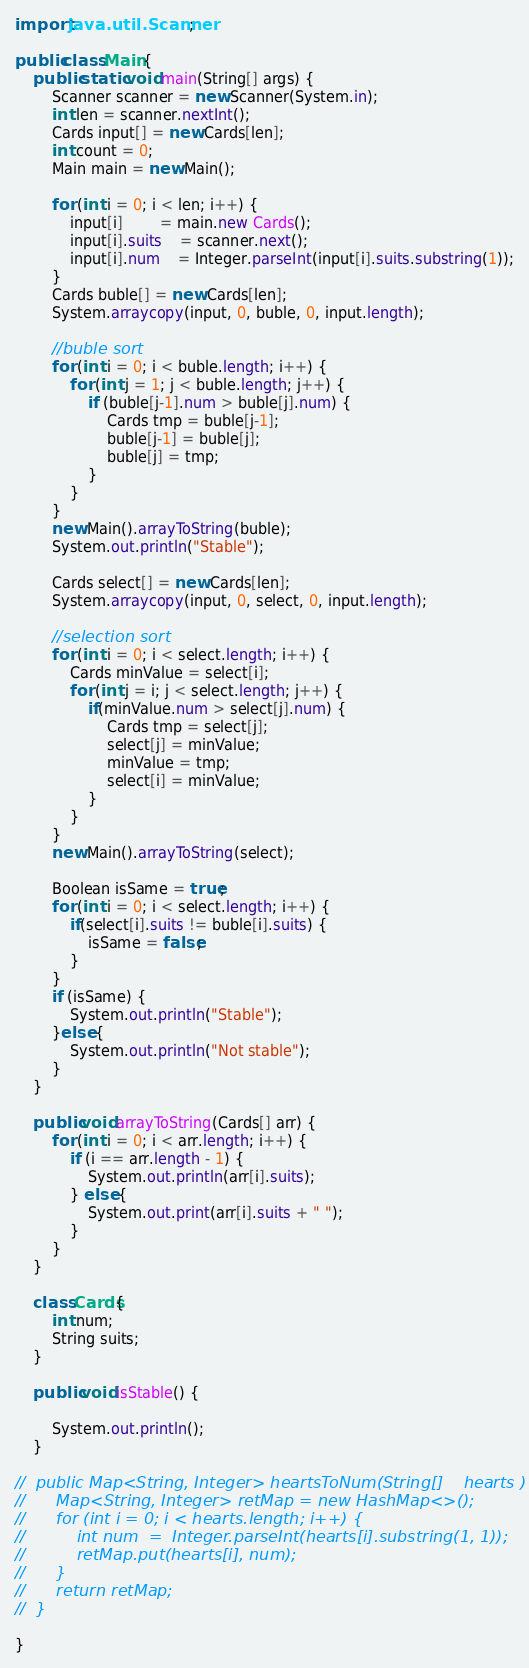Convert code to text. <code><loc_0><loc_0><loc_500><loc_500><_Java_>import java.util.Scanner;

public class Main {
	public static void main(String[] args) {
		Scanner scanner = new Scanner(System.in);
		int len = scanner.nextInt();
		Cards input[] = new Cards[len];
		int count = 0;
		Main main = new Main();

		for (int i = 0; i < len; i++) {
			input[i] 		= main.new Cards();
			input[i].suits 	= scanner.next();
			input[i].num 	= Integer.parseInt(input[i].suits.substring(1));
		}
		Cards buble[] = new Cards[len];
		System.arraycopy(input, 0, buble, 0, input.length);
		
		//buble sort
		for (int i = 0; i < buble.length; i++) {
			for (int j = 1; j < buble.length; j++) {
				if (buble[j-1].num > buble[j].num) {
					Cards tmp = buble[j-1];
					buble[j-1] = buble[j];
					buble[j] = tmp;
				}
			}
		}
		new Main().arrayToString(buble);
		System.out.println("Stable");
		
		Cards select[] = new Cards[len];
		System.arraycopy(input, 0, select, 0, input.length);
		
		//selection sort
		for (int i = 0; i < select.length; i++) {
			Cards minValue = select[i];
			for (int j = i; j < select.length; j++) {
				if(minValue.num > select[j].num) {
					Cards tmp = select[j];
					select[j] = minValue;
					minValue = tmp;
					select[i] = minValue;					
				}
			}
		}
		new Main().arrayToString(select);
		
		Boolean isSame = true;
		for (int i = 0; i < select.length; i++) {
			if(select[i].suits != buble[i].suits) {
				isSame = false;
			}
		}
		if (isSame) {
			System.out.println("Stable");
		}else {
			System.out.println("Not stable");
		}
	}

	public void arrayToString(Cards[] arr) {
		for (int i = 0; i < arr.length; i++) {
			if (i == arr.length - 1) {
				System.out.println(arr[i].suits);
			} else {
				System.out.print(arr[i].suits + " ");
			}
		}
	}
	
	class Cards{
		int num;
		String suits;
	}
	
	public void isStable() {
		
		System.out.println();
	}
	
//	public Map<String, Integer> heartsToNum(String[]	hearts ) {
//		Map<String, Integer> retMap = new HashMap<>();
//		for (int i = 0; i < hearts.length; i++) {
//			int	num  = 	Integer.parseInt(hearts[i].substring(1, 1));
//			retMap.put(hearts[i], num);
//		}
//		return retMap;
//	}

}
</code> 